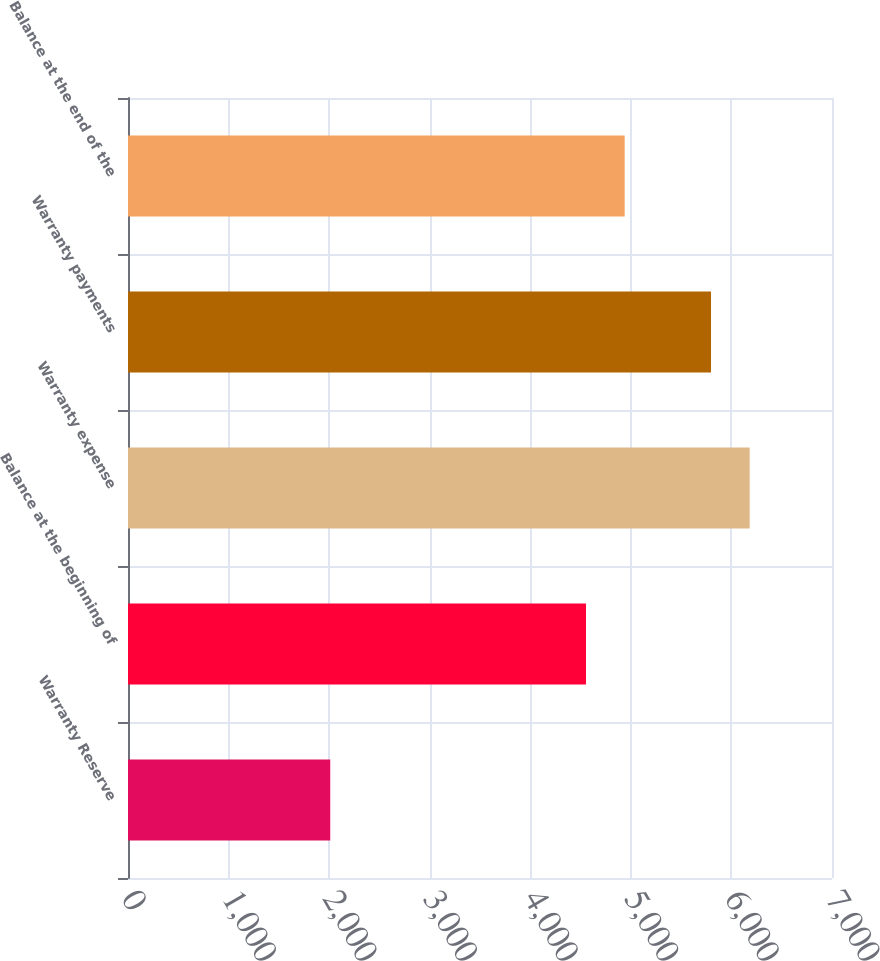Convert chart. <chart><loc_0><loc_0><loc_500><loc_500><bar_chart><fcel>Warranty Reserve<fcel>Balance at the beginning of<fcel>Warranty expense<fcel>Warranty payments<fcel>Balance at the end of the<nl><fcel>2011<fcel>4554<fcel>6181.5<fcel>5797<fcel>4938.5<nl></chart> 